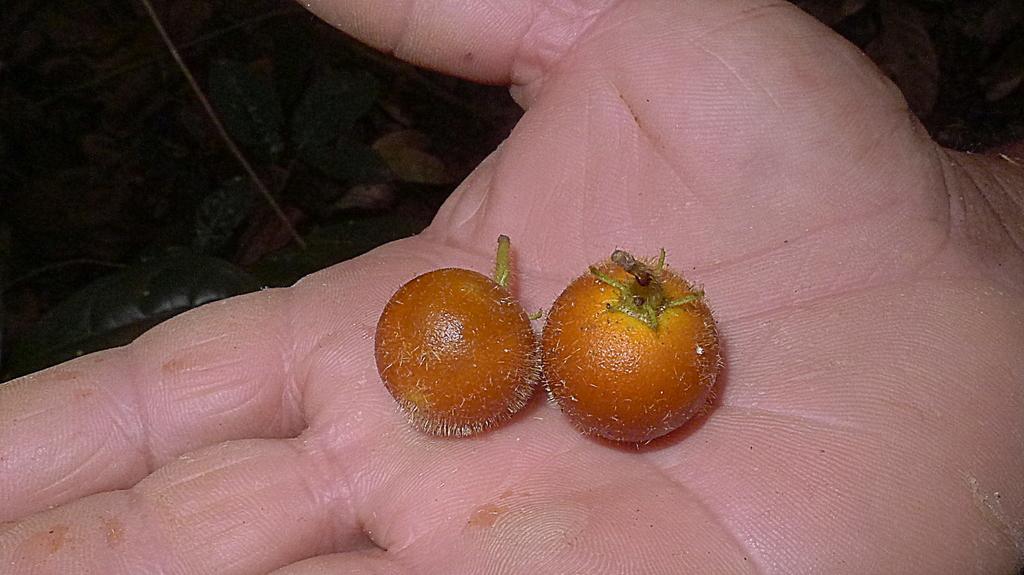Can you describe this image briefly? In this image, we can see human hand with some objects. Background we can see leaves. 